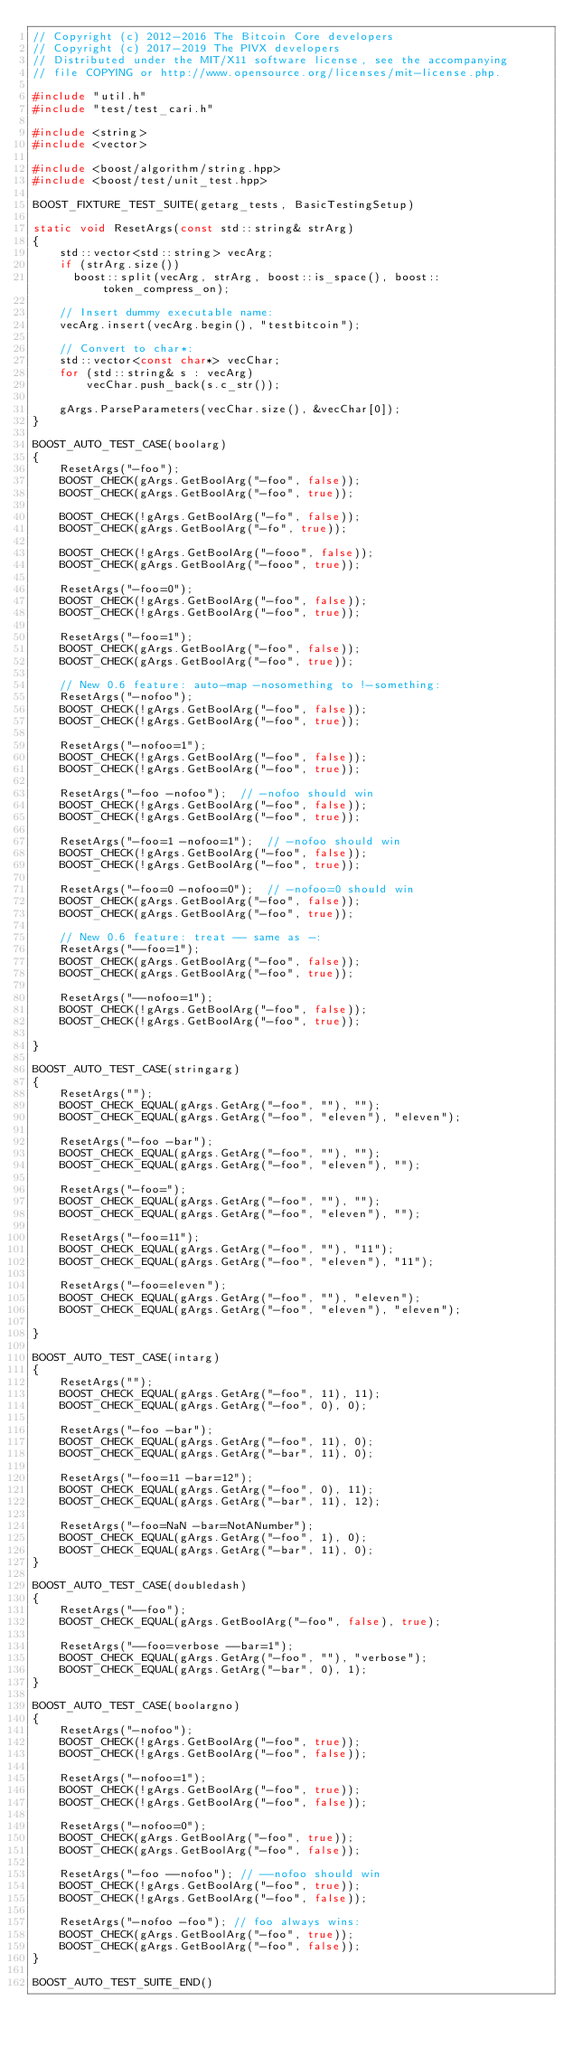<code> <loc_0><loc_0><loc_500><loc_500><_C++_>// Copyright (c) 2012-2016 The Bitcoin Core developers
// Copyright (c) 2017-2019 The PIVX developers
// Distributed under the MIT/X11 software license, see the accompanying
// file COPYING or http://www.opensource.org/licenses/mit-license.php.

#include "util.h"
#include "test/test_cari.h"

#include <string>
#include <vector>

#include <boost/algorithm/string.hpp>
#include <boost/test/unit_test.hpp>

BOOST_FIXTURE_TEST_SUITE(getarg_tests, BasicTestingSetup)

static void ResetArgs(const std::string& strArg)
{
    std::vector<std::string> vecArg;
    if (strArg.size())
      boost::split(vecArg, strArg, boost::is_space(), boost::token_compress_on);

    // Insert dummy executable name:
    vecArg.insert(vecArg.begin(), "testbitcoin");

    // Convert to char*:
    std::vector<const char*> vecChar;
    for (std::string& s : vecArg)
        vecChar.push_back(s.c_str());

    gArgs.ParseParameters(vecChar.size(), &vecChar[0]);
}

BOOST_AUTO_TEST_CASE(boolarg)
{
    ResetArgs("-foo");
    BOOST_CHECK(gArgs.GetBoolArg("-foo", false));
    BOOST_CHECK(gArgs.GetBoolArg("-foo", true));

    BOOST_CHECK(!gArgs.GetBoolArg("-fo", false));
    BOOST_CHECK(gArgs.GetBoolArg("-fo", true));

    BOOST_CHECK(!gArgs.GetBoolArg("-fooo", false));
    BOOST_CHECK(gArgs.GetBoolArg("-fooo", true));

    ResetArgs("-foo=0");
    BOOST_CHECK(!gArgs.GetBoolArg("-foo", false));
    BOOST_CHECK(!gArgs.GetBoolArg("-foo", true));

    ResetArgs("-foo=1");
    BOOST_CHECK(gArgs.GetBoolArg("-foo", false));
    BOOST_CHECK(gArgs.GetBoolArg("-foo", true));

    // New 0.6 feature: auto-map -nosomething to !-something:
    ResetArgs("-nofoo");
    BOOST_CHECK(!gArgs.GetBoolArg("-foo", false));
    BOOST_CHECK(!gArgs.GetBoolArg("-foo", true));

    ResetArgs("-nofoo=1");
    BOOST_CHECK(!gArgs.GetBoolArg("-foo", false));
    BOOST_CHECK(!gArgs.GetBoolArg("-foo", true));

    ResetArgs("-foo -nofoo");  // -nofoo should win
    BOOST_CHECK(!gArgs.GetBoolArg("-foo", false));
    BOOST_CHECK(!gArgs.GetBoolArg("-foo", true));

    ResetArgs("-foo=1 -nofoo=1");  // -nofoo should win
    BOOST_CHECK(!gArgs.GetBoolArg("-foo", false));
    BOOST_CHECK(!gArgs.GetBoolArg("-foo", true));

    ResetArgs("-foo=0 -nofoo=0");  // -nofoo=0 should win
    BOOST_CHECK(gArgs.GetBoolArg("-foo", false));
    BOOST_CHECK(gArgs.GetBoolArg("-foo", true));

    // New 0.6 feature: treat -- same as -:
    ResetArgs("--foo=1");
    BOOST_CHECK(gArgs.GetBoolArg("-foo", false));
    BOOST_CHECK(gArgs.GetBoolArg("-foo", true));

    ResetArgs("--nofoo=1");
    BOOST_CHECK(!gArgs.GetBoolArg("-foo", false));
    BOOST_CHECK(!gArgs.GetBoolArg("-foo", true));

}

BOOST_AUTO_TEST_CASE(stringarg)
{
    ResetArgs("");
    BOOST_CHECK_EQUAL(gArgs.GetArg("-foo", ""), "");
    BOOST_CHECK_EQUAL(gArgs.GetArg("-foo", "eleven"), "eleven");

    ResetArgs("-foo -bar");
    BOOST_CHECK_EQUAL(gArgs.GetArg("-foo", ""), "");
    BOOST_CHECK_EQUAL(gArgs.GetArg("-foo", "eleven"), "");

    ResetArgs("-foo=");
    BOOST_CHECK_EQUAL(gArgs.GetArg("-foo", ""), "");
    BOOST_CHECK_EQUAL(gArgs.GetArg("-foo", "eleven"), "");

    ResetArgs("-foo=11");
    BOOST_CHECK_EQUAL(gArgs.GetArg("-foo", ""), "11");
    BOOST_CHECK_EQUAL(gArgs.GetArg("-foo", "eleven"), "11");

    ResetArgs("-foo=eleven");
    BOOST_CHECK_EQUAL(gArgs.GetArg("-foo", ""), "eleven");
    BOOST_CHECK_EQUAL(gArgs.GetArg("-foo", "eleven"), "eleven");

}

BOOST_AUTO_TEST_CASE(intarg)
{
    ResetArgs("");
    BOOST_CHECK_EQUAL(gArgs.GetArg("-foo", 11), 11);
    BOOST_CHECK_EQUAL(gArgs.GetArg("-foo", 0), 0);

    ResetArgs("-foo -bar");
    BOOST_CHECK_EQUAL(gArgs.GetArg("-foo", 11), 0);
    BOOST_CHECK_EQUAL(gArgs.GetArg("-bar", 11), 0);

    ResetArgs("-foo=11 -bar=12");
    BOOST_CHECK_EQUAL(gArgs.GetArg("-foo", 0), 11);
    BOOST_CHECK_EQUAL(gArgs.GetArg("-bar", 11), 12);

    ResetArgs("-foo=NaN -bar=NotANumber");
    BOOST_CHECK_EQUAL(gArgs.GetArg("-foo", 1), 0);
    BOOST_CHECK_EQUAL(gArgs.GetArg("-bar", 11), 0);
}

BOOST_AUTO_TEST_CASE(doubledash)
{
    ResetArgs("--foo");
    BOOST_CHECK_EQUAL(gArgs.GetBoolArg("-foo", false), true);

    ResetArgs("--foo=verbose --bar=1");
    BOOST_CHECK_EQUAL(gArgs.GetArg("-foo", ""), "verbose");
    BOOST_CHECK_EQUAL(gArgs.GetArg("-bar", 0), 1);
}

BOOST_AUTO_TEST_CASE(boolargno)
{
    ResetArgs("-nofoo");
    BOOST_CHECK(!gArgs.GetBoolArg("-foo", true));
    BOOST_CHECK(!gArgs.GetBoolArg("-foo", false));

    ResetArgs("-nofoo=1");
    BOOST_CHECK(!gArgs.GetBoolArg("-foo", true));
    BOOST_CHECK(!gArgs.GetBoolArg("-foo", false));

    ResetArgs("-nofoo=0");
    BOOST_CHECK(gArgs.GetBoolArg("-foo", true));
    BOOST_CHECK(gArgs.GetBoolArg("-foo", false));

    ResetArgs("-foo --nofoo"); // --nofoo should win
    BOOST_CHECK(!gArgs.GetBoolArg("-foo", true));
    BOOST_CHECK(!gArgs.GetBoolArg("-foo", false));

    ResetArgs("-nofoo -foo"); // foo always wins:
    BOOST_CHECK(gArgs.GetBoolArg("-foo", true));
    BOOST_CHECK(gArgs.GetBoolArg("-foo", false));
}

BOOST_AUTO_TEST_SUITE_END()
</code> 